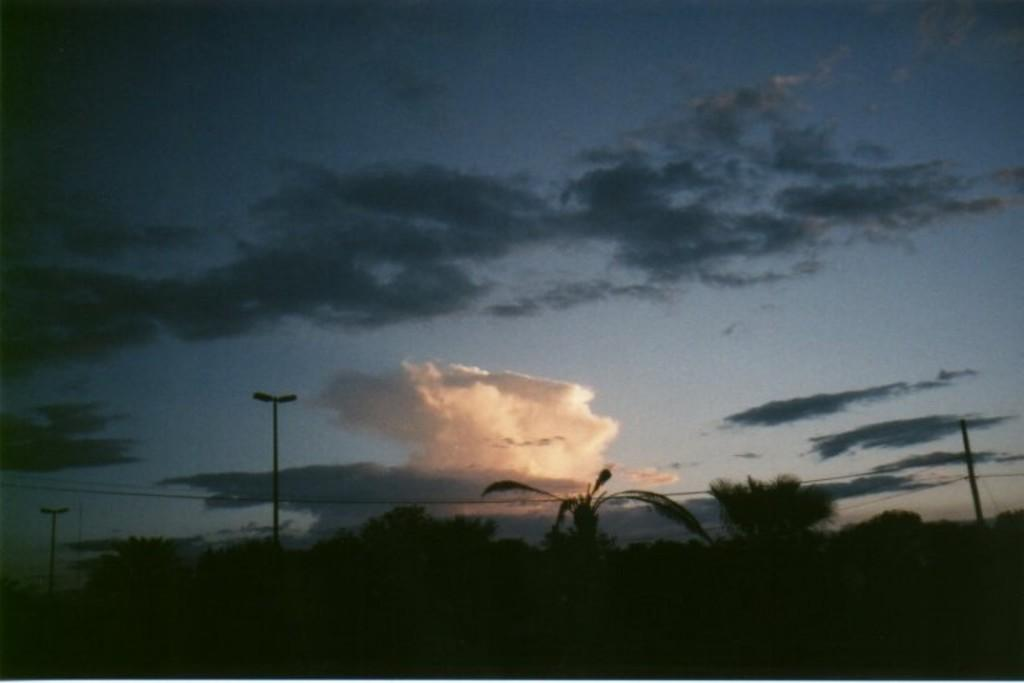Where was the image taken? The image is taken outdoors. What can be seen in the sky in the image? There is a sky with clouds visible in the image. What type of vegetation is present at the bottom of the image? There are trees at the bottom of the image. How many poles with street lights are in the image? There are three poles with street lights in the image. What type of suit is the family wearing in the image? There is no family or suit present in the image. What songs are being sung by the people in the image? There are no people or songs present in the image. 